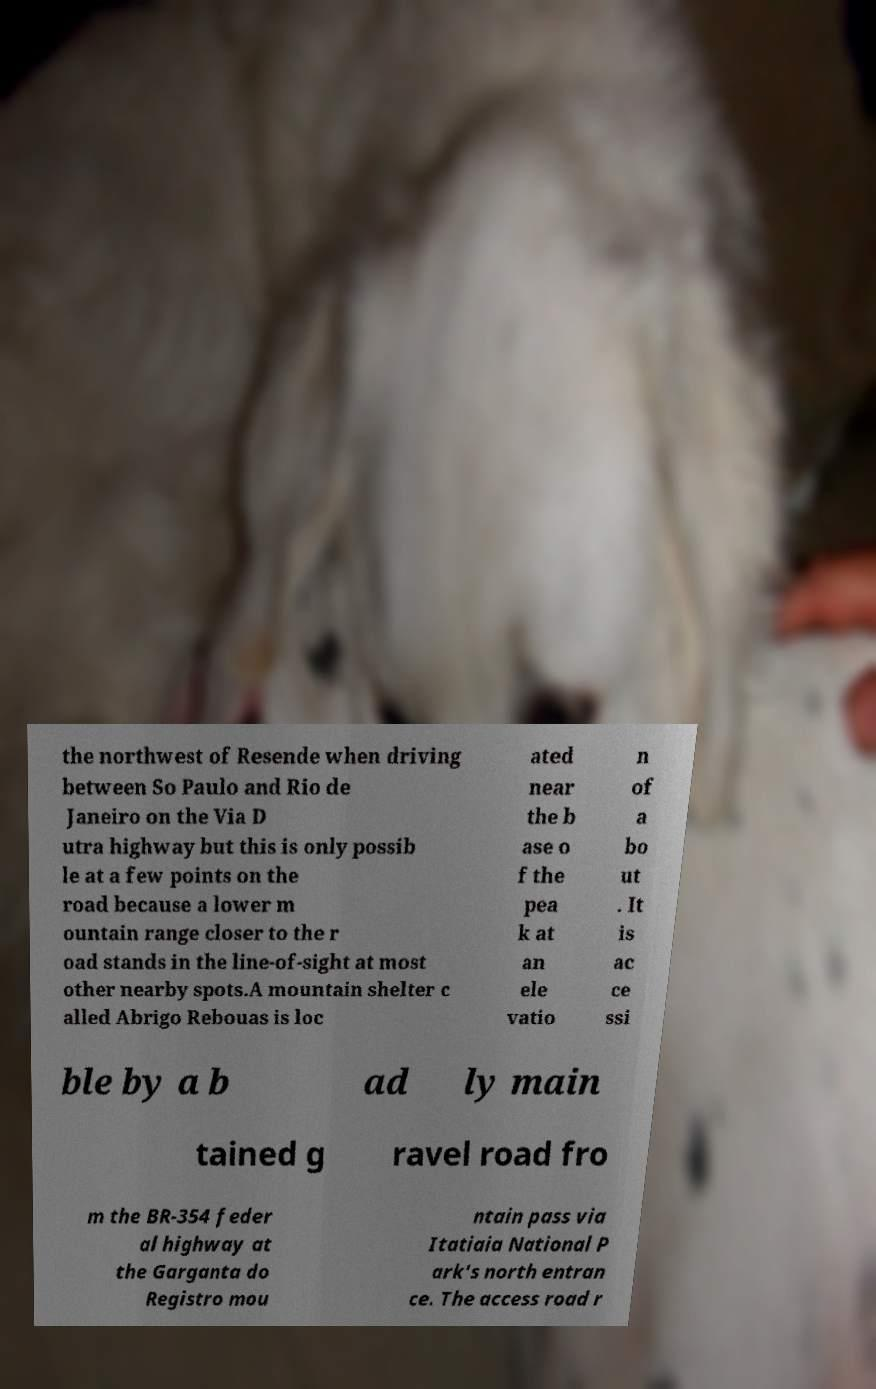There's text embedded in this image that I need extracted. Can you transcribe it verbatim? the northwest of Resende when driving between So Paulo and Rio de Janeiro on the Via D utra highway but this is only possib le at a few points on the road because a lower m ountain range closer to the r oad stands in the line-of-sight at most other nearby spots.A mountain shelter c alled Abrigo Rebouas is loc ated near the b ase o f the pea k at an ele vatio n of a bo ut . It is ac ce ssi ble by a b ad ly main tained g ravel road fro m the BR-354 feder al highway at the Garganta do Registro mou ntain pass via Itatiaia National P ark's north entran ce. The access road r 